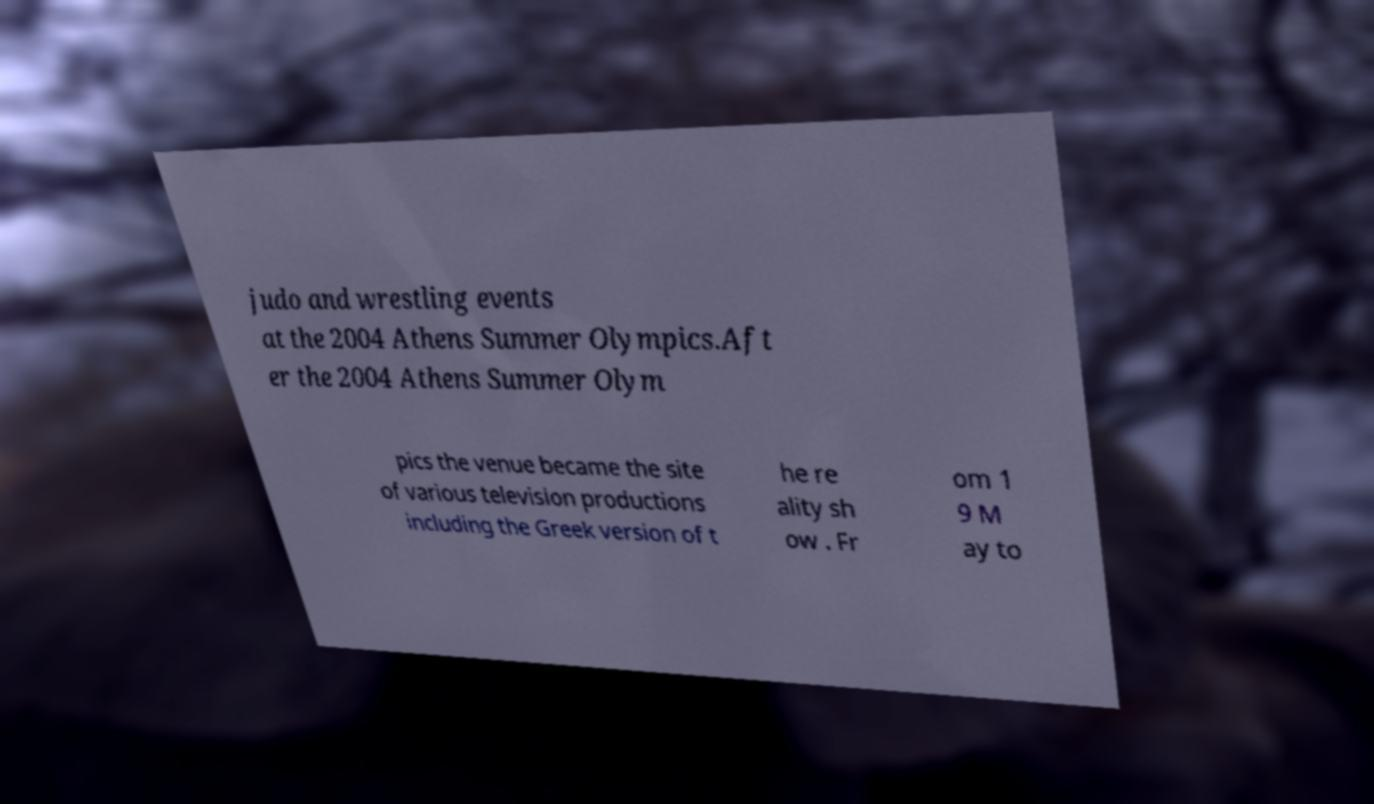There's text embedded in this image that I need extracted. Can you transcribe it verbatim? judo and wrestling events at the 2004 Athens Summer Olympics.Aft er the 2004 Athens Summer Olym pics the venue became the site of various television productions including the Greek version of t he re ality sh ow . Fr om 1 9 M ay to 